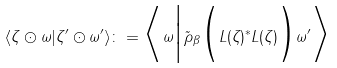Convert formula to latex. <formula><loc_0><loc_0><loc_500><loc_500>\langle \zeta \odot \omega | \zeta ^ { \prime } \odot \omega ^ { \prime } \rangle \colon = \Big \langle \omega \Big | \tilde { \rho } _ { \beta } \Big ( L ( \zeta ) ^ { * } L ( \zeta ) \Big ) \omega ^ { \prime } \Big \rangle</formula> 